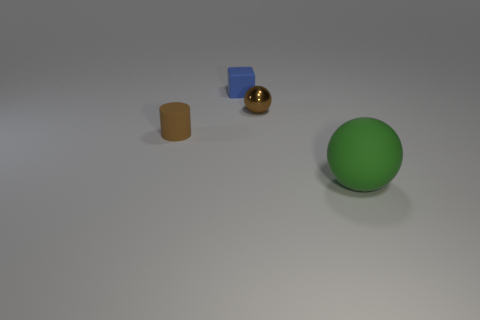Could you suggest an activity that might involve all these objects? These objects could be used in a physics demonstration involving the properties of different materials, such as comparing their rolling speeds, how they reflect light, or their surface friction when interacting with the plane beneath them. 